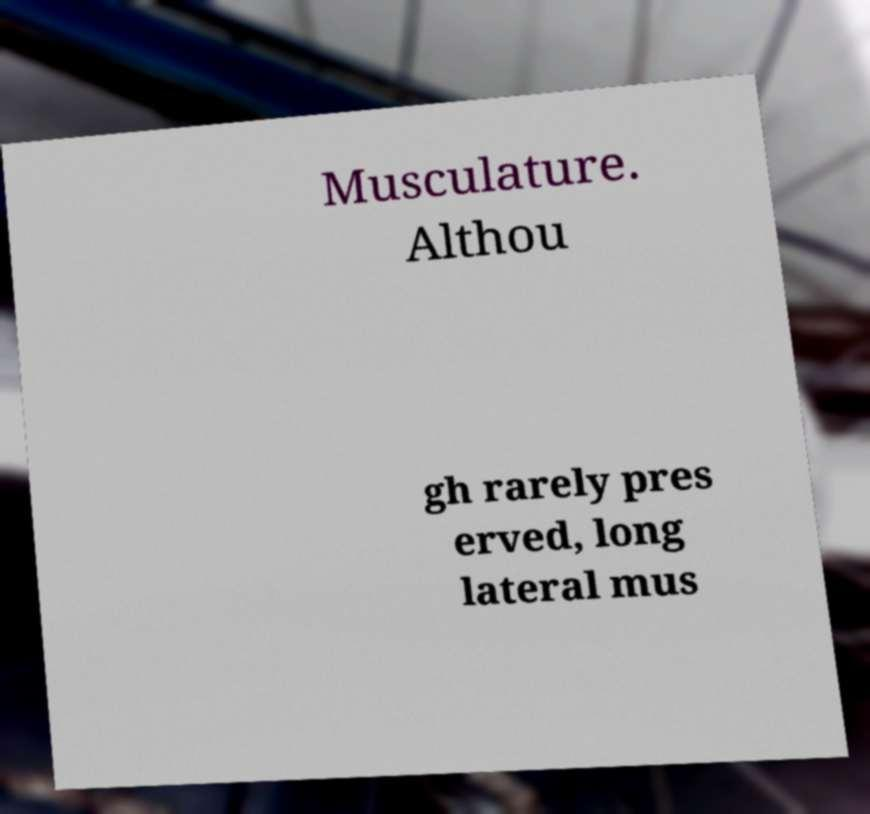For documentation purposes, I need the text within this image transcribed. Could you provide that? Musculature. Althou gh rarely pres erved, long lateral mus 